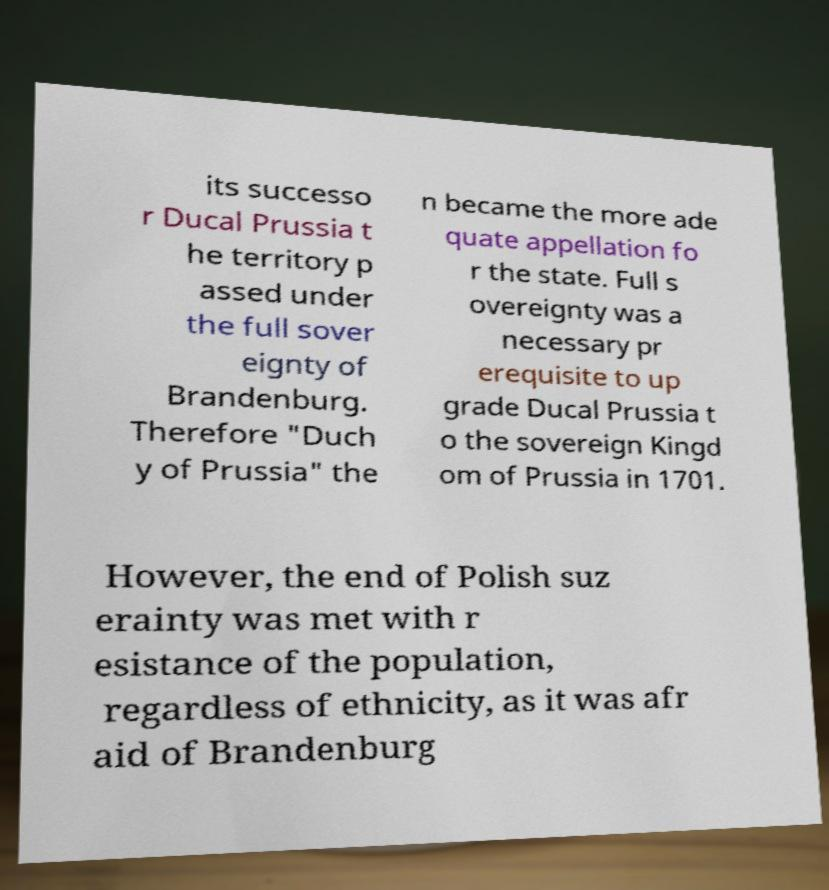Can you accurately transcribe the text from the provided image for me? its successo r Ducal Prussia t he territory p assed under the full sover eignty of Brandenburg. Therefore "Duch y of Prussia" the n became the more ade quate appellation fo r the state. Full s overeignty was a necessary pr erequisite to up grade Ducal Prussia t o the sovereign Kingd om of Prussia in 1701. However, the end of Polish suz erainty was met with r esistance of the population, regardless of ethnicity, as it was afr aid of Brandenburg 